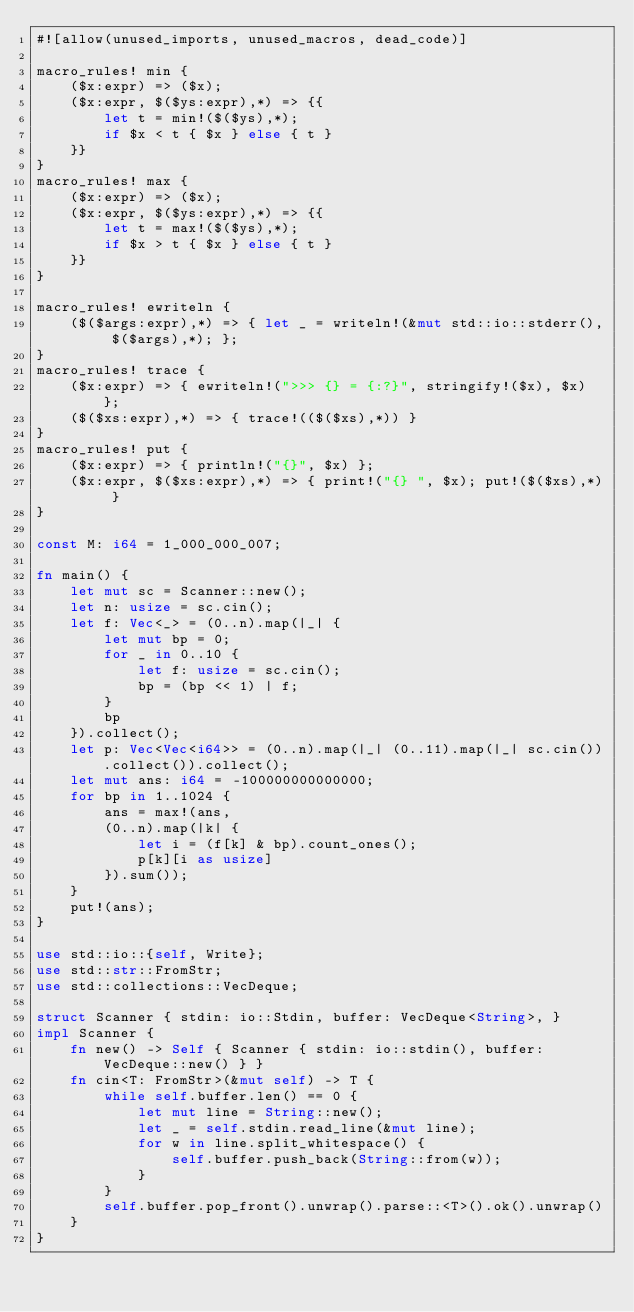<code> <loc_0><loc_0><loc_500><loc_500><_Rust_>#![allow(unused_imports, unused_macros, dead_code)]

macro_rules! min {
    ($x:expr) => ($x);
    ($x:expr, $($ys:expr),*) => {{
        let t = min!($($ys),*);
        if $x < t { $x } else { t }
    }}
}
macro_rules! max {
    ($x:expr) => ($x);
    ($x:expr, $($ys:expr),*) => {{
        let t = max!($($ys),*);
        if $x > t { $x } else { t }
    }}
}

macro_rules! ewriteln {
    ($($args:expr),*) => { let _ = writeln!(&mut std::io::stderr(), $($args),*); };
}
macro_rules! trace {
    ($x:expr) => { ewriteln!(">>> {} = {:?}", stringify!($x), $x) };
    ($($xs:expr),*) => { trace!(($($xs),*)) }
}
macro_rules! put {
    ($x:expr) => { println!("{}", $x) };
    ($x:expr, $($xs:expr),*) => { print!("{} ", $x); put!($($xs),*) }
}

const M: i64 = 1_000_000_007;

fn main() {
    let mut sc = Scanner::new();
    let n: usize = sc.cin();
    let f: Vec<_> = (0..n).map(|_| {
        let mut bp = 0;
        for _ in 0..10 {
            let f: usize = sc.cin();
            bp = (bp << 1) | f;
        }
        bp
    }).collect();
    let p: Vec<Vec<i64>> = (0..n).map(|_| (0..11).map(|_| sc.cin()).collect()).collect();
    let mut ans: i64 = -100000000000000;
    for bp in 1..1024 {
        ans = max!(ans,
        (0..n).map(|k| {
            let i = (f[k] & bp).count_ones();
            p[k][i as usize]
        }).sum());
    }
    put!(ans);
}

use std::io::{self, Write};
use std::str::FromStr;
use std::collections::VecDeque;

struct Scanner { stdin: io::Stdin, buffer: VecDeque<String>, }
impl Scanner {
    fn new() -> Self { Scanner { stdin: io::stdin(), buffer: VecDeque::new() } }
    fn cin<T: FromStr>(&mut self) -> T {
        while self.buffer.len() == 0 {
            let mut line = String::new();
            let _ = self.stdin.read_line(&mut line);
            for w in line.split_whitespace() {
                self.buffer.push_back(String::from(w));
            }
        }
        self.buffer.pop_front().unwrap().parse::<T>().ok().unwrap()
    }
}
</code> 